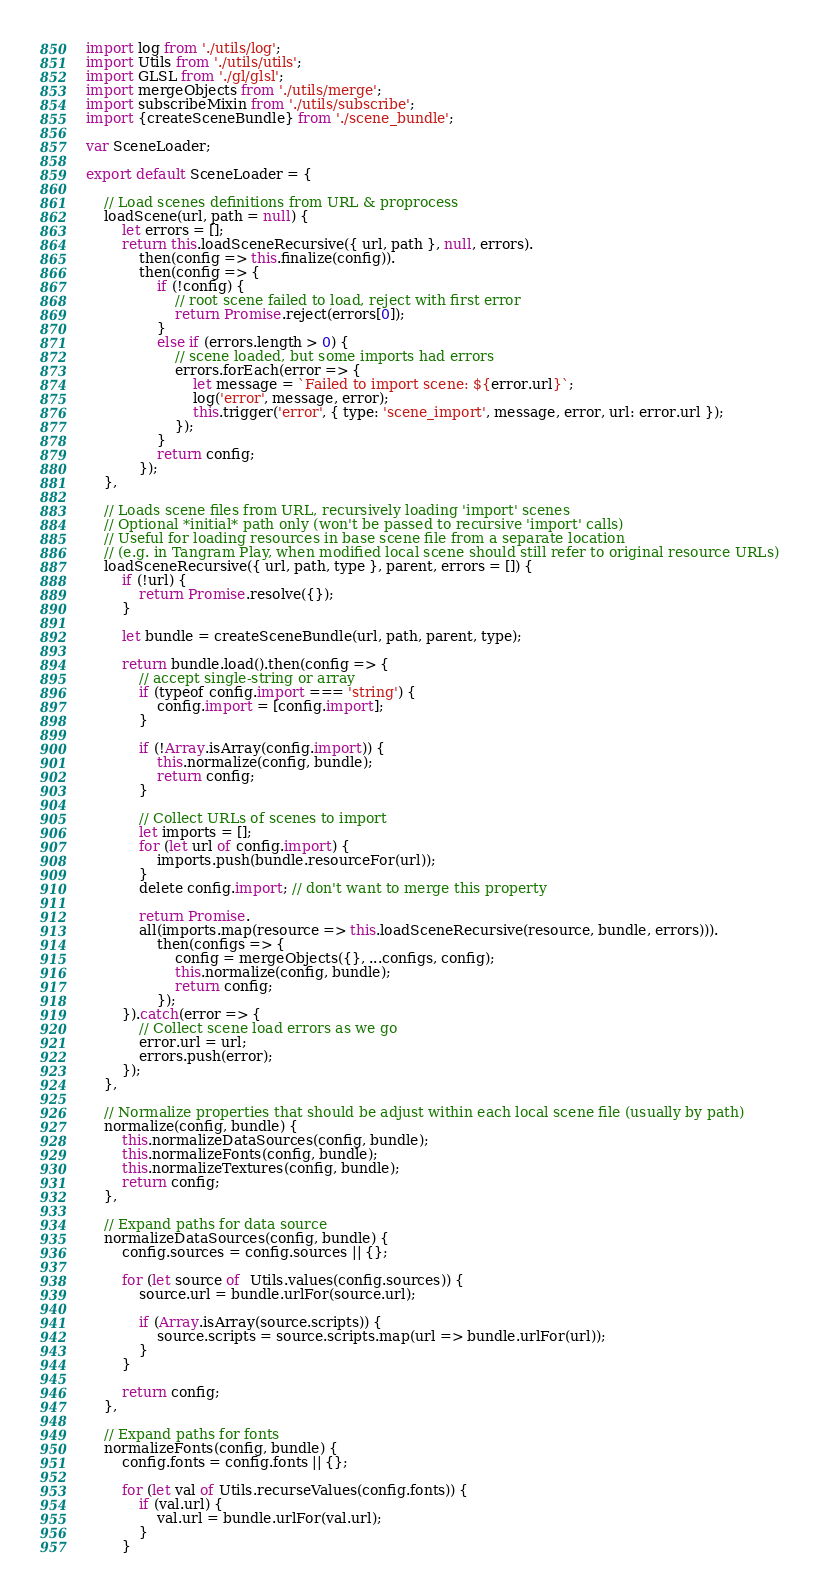<code> <loc_0><loc_0><loc_500><loc_500><_JavaScript_>import log from './utils/log';
import Utils from './utils/utils';
import GLSL from './gl/glsl';
import mergeObjects from './utils/merge';
import subscribeMixin from './utils/subscribe';
import {createSceneBundle} from './scene_bundle';

var SceneLoader;

export default SceneLoader = {

    // Load scenes definitions from URL & proprocess
    loadScene(url, path = null) {
        let errors = [];
        return this.loadSceneRecursive({ url, path }, null, errors).
            then(config => this.finalize(config)).
            then(config => {
                if (!config) {
                    // root scene failed to load, reject with first error
                    return Promise.reject(errors[0]);
                }
                else if (errors.length > 0) {
                    // scene loaded, but some imports had errors
                    errors.forEach(error => {
                        let message = `Failed to import scene: ${error.url}`;
                        log('error', message, error);
                        this.trigger('error', { type: 'scene_import', message, error, url: error.url });
                    });
                }
                return config;
            });
    },

    // Loads scene files from URL, recursively loading 'import' scenes
    // Optional *initial* path only (won't be passed to recursive 'import' calls)
    // Useful for loading resources in base scene file from a separate location
    // (e.g. in Tangram Play, when modified local scene should still refer to original resource URLs)
    loadSceneRecursive({ url, path, type }, parent, errors = []) {
        if (!url) {
            return Promise.resolve({});
        }

        let bundle = createSceneBundle(url, path, parent, type);

        return bundle.load().then(config => {
            // accept single-string or array
            if (typeof config.import === 'string') {
                config.import = [config.import];
            }

            if (!Array.isArray(config.import)) {
                this.normalize(config, bundle);
                return config;
            }

            // Collect URLs of scenes to import
            let imports = [];
            for (let url of config.import) {
                imports.push(bundle.resourceFor(url));
            }
            delete config.import; // don't want to merge this property

            return Promise.
            all(imports.map(resource => this.loadSceneRecursive(resource, bundle, errors))).
                then(configs => {
                    config = mergeObjects({}, ...configs, config);
                    this.normalize(config, bundle);
                    return config;
                });
        }).catch(error => {
            // Collect scene load errors as we go
            error.url = url;
            errors.push(error);
        });
    },

    // Normalize properties that should be adjust within each local scene file (usually by path)
    normalize(config, bundle) {
        this.normalizeDataSources(config, bundle);
        this.normalizeFonts(config, bundle);
        this.normalizeTextures(config, bundle);
        return config;
    },

    // Expand paths for data source
    normalizeDataSources(config, bundle) {
        config.sources = config.sources || {};

        for (let source of  Utils.values(config.sources)) {
            source.url = bundle.urlFor(source.url);

            if (Array.isArray(source.scripts)) {
                source.scripts = source.scripts.map(url => bundle.urlFor(url));
            }
        }

        return config;
    },

    // Expand paths for fonts
    normalizeFonts(config, bundle) {
        config.fonts = config.fonts || {};

        for (let val of Utils.recurseValues(config.fonts)) {
            if (val.url) {
                val.url = bundle.urlFor(val.url);
            }
        }
</code> 